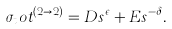Convert formula to latex. <formula><loc_0><loc_0><loc_500><loc_500>\sigma _ { t } o t ^ { ( 2 \rightarrow 2 ) } = D s ^ { \epsilon } + E s ^ { - \delta } .</formula> 